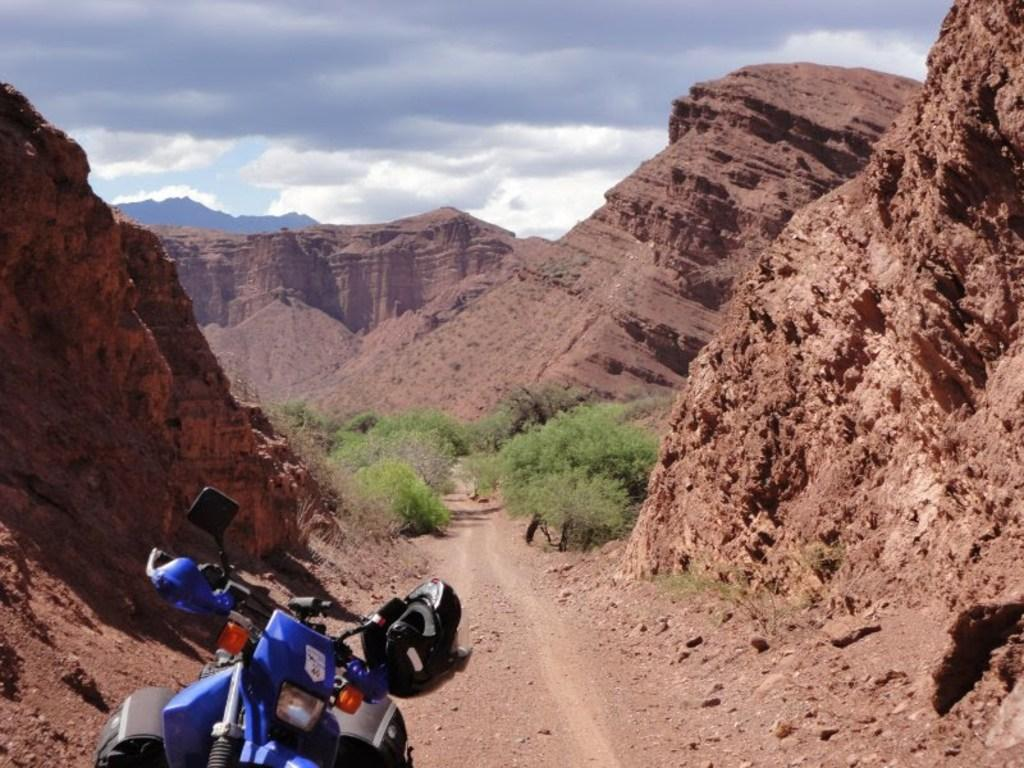What is located at the bottom of the image? There is a bike at the bottom of the image. What safety accessory is present with the bike? A helmet is present with the bike. What type of vegetation is behind the bike? There are plants behind the bike. What type of terrain is visible in the image? Hills are visible in the image. What is visible at the top of the image? The sky is visible at the top of the image. What can be seen in the sky? Clouds are present in the sky. What degree does the governor have in the image? There is no governor present in the image, so it is not possible to determine their degree. What type of brush is used to clean the bike in the image? There is no brush visible in the image, and it is not possible to determine how the bike is cleaned. 